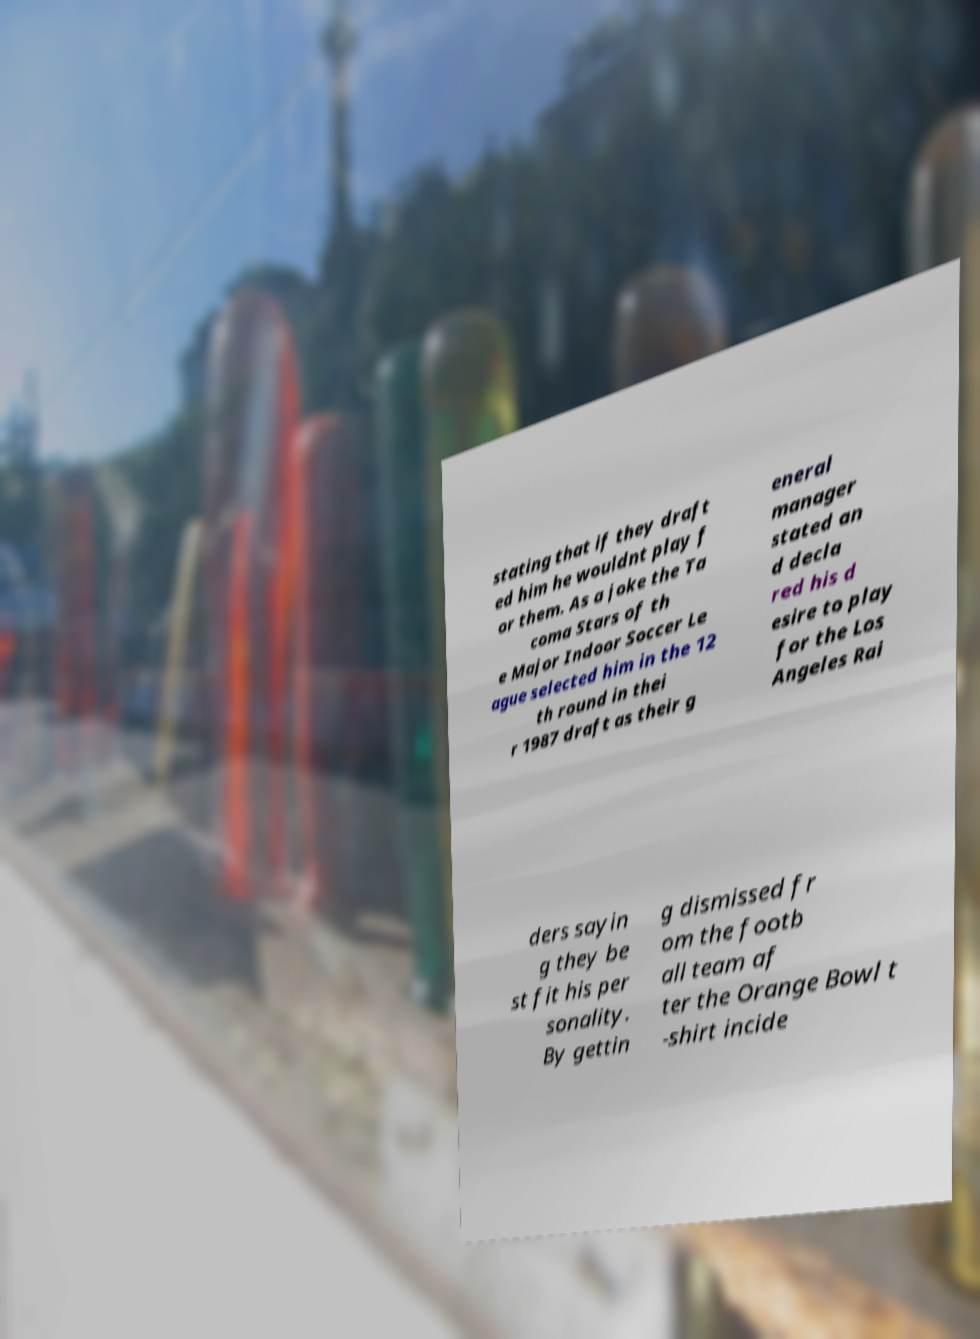Please read and relay the text visible in this image. What does it say? stating that if they draft ed him he wouldnt play f or them. As a joke the Ta coma Stars of th e Major Indoor Soccer Le ague selected him in the 12 th round in thei r 1987 draft as their g eneral manager stated an d decla red his d esire to play for the Los Angeles Rai ders sayin g they be st fit his per sonality. By gettin g dismissed fr om the footb all team af ter the Orange Bowl t -shirt incide 